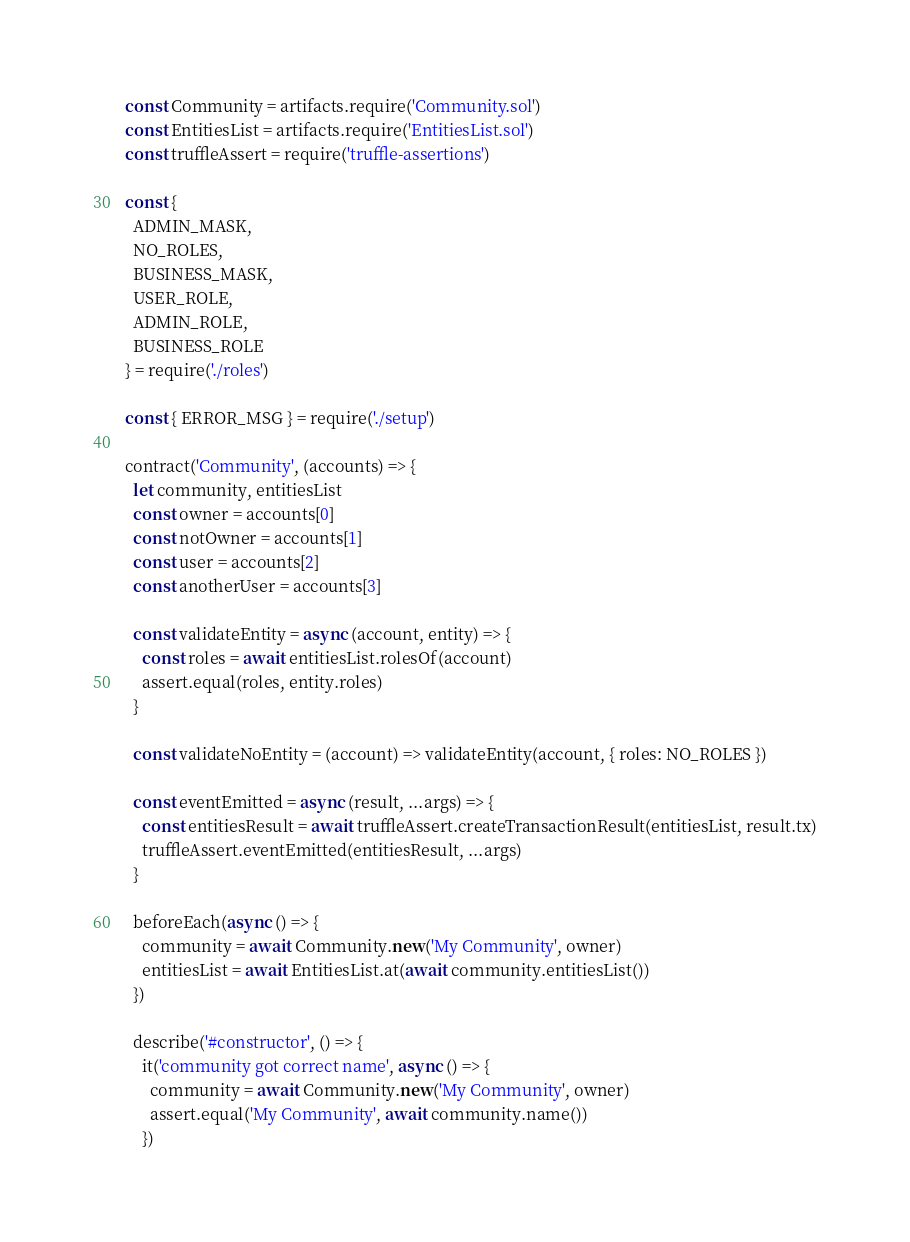Convert code to text. <code><loc_0><loc_0><loc_500><loc_500><_JavaScript_>const Community = artifacts.require('Community.sol')
const EntitiesList = artifacts.require('EntitiesList.sol')
const truffleAssert = require('truffle-assertions')

const {
  ADMIN_MASK,
  NO_ROLES,
  BUSINESS_MASK,
  USER_ROLE,
  ADMIN_ROLE,
  BUSINESS_ROLE
} = require('./roles')

const { ERROR_MSG } = require('./setup')

contract('Community', (accounts) => {
  let community, entitiesList
  const owner = accounts[0]
  const notOwner = accounts[1]
  const user = accounts[2]
  const anotherUser = accounts[3]

  const validateEntity = async (account, entity) => {
    const roles = await entitiesList.rolesOf(account)
    assert.equal(roles, entity.roles)
  }

  const validateNoEntity = (account) => validateEntity(account, { roles: NO_ROLES })

  const eventEmitted = async (result, ...args) => {
    const entitiesResult = await truffleAssert.createTransactionResult(entitiesList, result.tx)
    truffleAssert.eventEmitted(entitiesResult, ...args)
  }

  beforeEach(async () => {
    community = await Community.new('My Community', owner)
    entitiesList = await EntitiesList.at(await community.entitiesList())
  })

  describe('#constructor', () => {
    it('community got correct name', async () => {
      community = await Community.new('My Community', owner)
      assert.equal('My Community', await community.name())
    })
</code> 